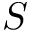<formula> <loc_0><loc_0><loc_500><loc_500>S</formula> 